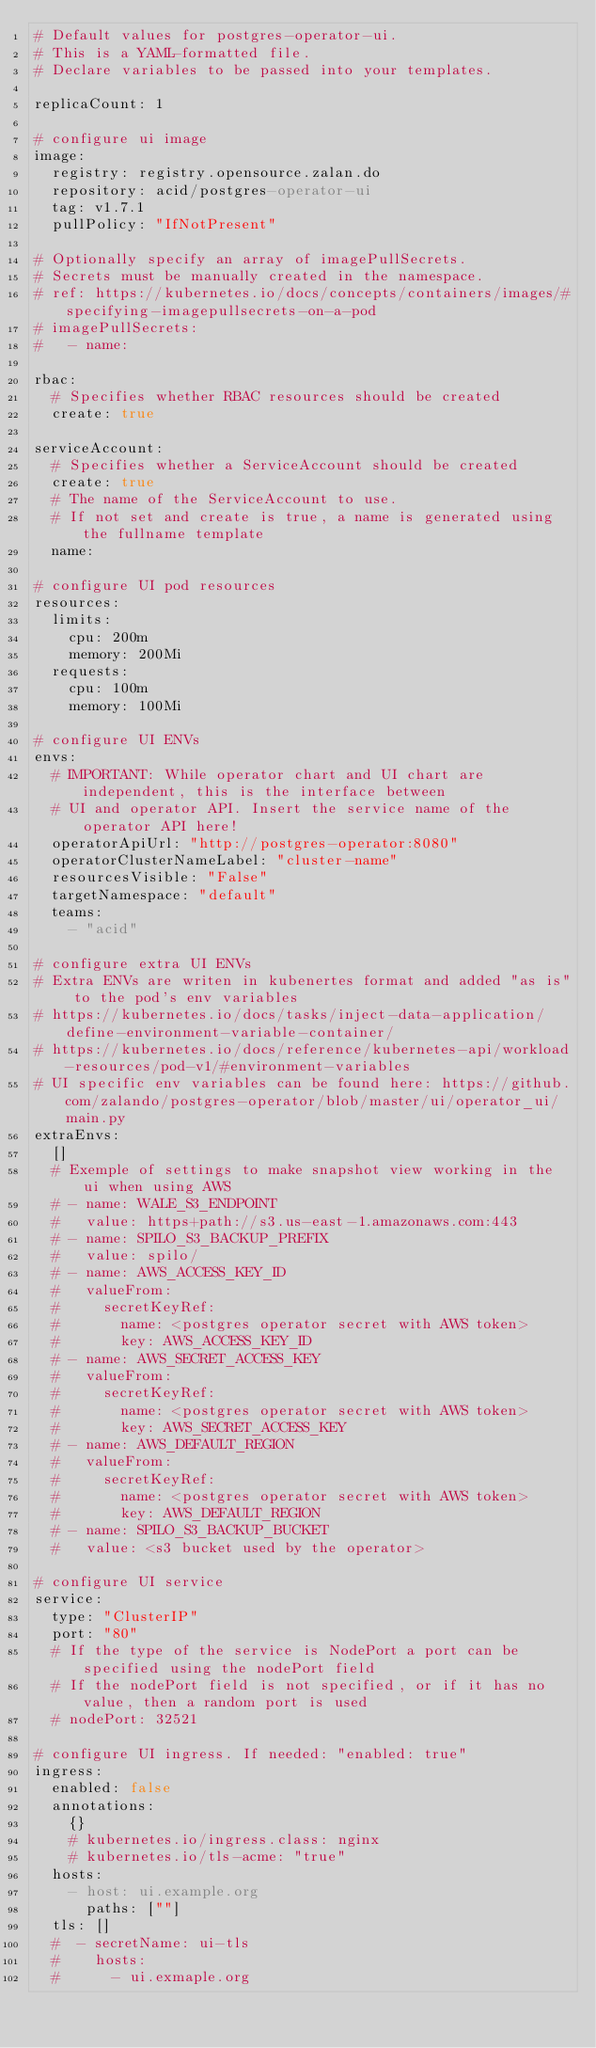<code> <loc_0><loc_0><loc_500><loc_500><_YAML_># Default values for postgres-operator-ui.
# This is a YAML-formatted file.
# Declare variables to be passed into your templates.

replicaCount: 1

# configure ui image
image:
  registry: registry.opensource.zalan.do
  repository: acid/postgres-operator-ui
  tag: v1.7.1
  pullPolicy: "IfNotPresent"

# Optionally specify an array of imagePullSecrets.
# Secrets must be manually created in the namespace.
# ref: https://kubernetes.io/docs/concepts/containers/images/#specifying-imagepullsecrets-on-a-pod
# imagePullSecrets:
#   - name:

rbac:
  # Specifies whether RBAC resources should be created
  create: true

serviceAccount:
  # Specifies whether a ServiceAccount should be created
  create: true
  # The name of the ServiceAccount to use.
  # If not set and create is true, a name is generated using the fullname template
  name:

# configure UI pod resources
resources:
  limits:
    cpu: 200m
    memory: 200Mi
  requests:
    cpu: 100m
    memory: 100Mi

# configure UI ENVs
envs:
  # IMPORTANT: While operator chart and UI chart are independent, this is the interface between
  # UI and operator API. Insert the service name of the operator API here!
  operatorApiUrl: "http://postgres-operator:8080"
  operatorClusterNameLabel: "cluster-name"
  resourcesVisible: "False"
  targetNamespace: "default"
  teams:
    - "acid"

# configure extra UI ENVs
# Extra ENVs are writen in kubenertes format and added "as is" to the pod's env variables
# https://kubernetes.io/docs/tasks/inject-data-application/define-environment-variable-container/
# https://kubernetes.io/docs/reference/kubernetes-api/workload-resources/pod-v1/#environment-variables
# UI specific env variables can be found here: https://github.com/zalando/postgres-operator/blob/master/ui/operator_ui/main.py
extraEnvs:
  []
  # Exemple of settings to make snapshot view working in the ui when using AWS
  # - name: WALE_S3_ENDPOINT
  #   value: https+path://s3.us-east-1.amazonaws.com:443
  # - name: SPILO_S3_BACKUP_PREFIX
  #   value: spilo/
  # - name: AWS_ACCESS_KEY_ID
  #   valueFrom:
  #     secretKeyRef:
  #       name: <postgres operator secret with AWS token>
  #       key: AWS_ACCESS_KEY_ID
  # - name: AWS_SECRET_ACCESS_KEY
  #   valueFrom:
  #     secretKeyRef:
  #       name: <postgres operator secret with AWS token>
  #       key: AWS_SECRET_ACCESS_KEY
  # - name: AWS_DEFAULT_REGION
  #   valueFrom:
  #     secretKeyRef:
  #       name: <postgres operator secret with AWS token>
  #       key: AWS_DEFAULT_REGION
  # - name: SPILO_S3_BACKUP_BUCKET
  #   value: <s3 bucket used by the operator>

# configure UI service
service:
  type: "ClusterIP"
  port: "80"
  # If the type of the service is NodePort a port can be specified using the nodePort field
  # If the nodePort field is not specified, or if it has no value, then a random port is used
  # nodePort: 32521

# configure UI ingress. If needed: "enabled: true"
ingress:
  enabled: false
  annotations:
    {}
    # kubernetes.io/ingress.class: nginx
    # kubernetes.io/tls-acme: "true"
  hosts:
    - host: ui.example.org
      paths: [""]
  tls: []
  #  - secretName: ui-tls
  #    hosts:
  #      - ui.exmaple.org
</code> 